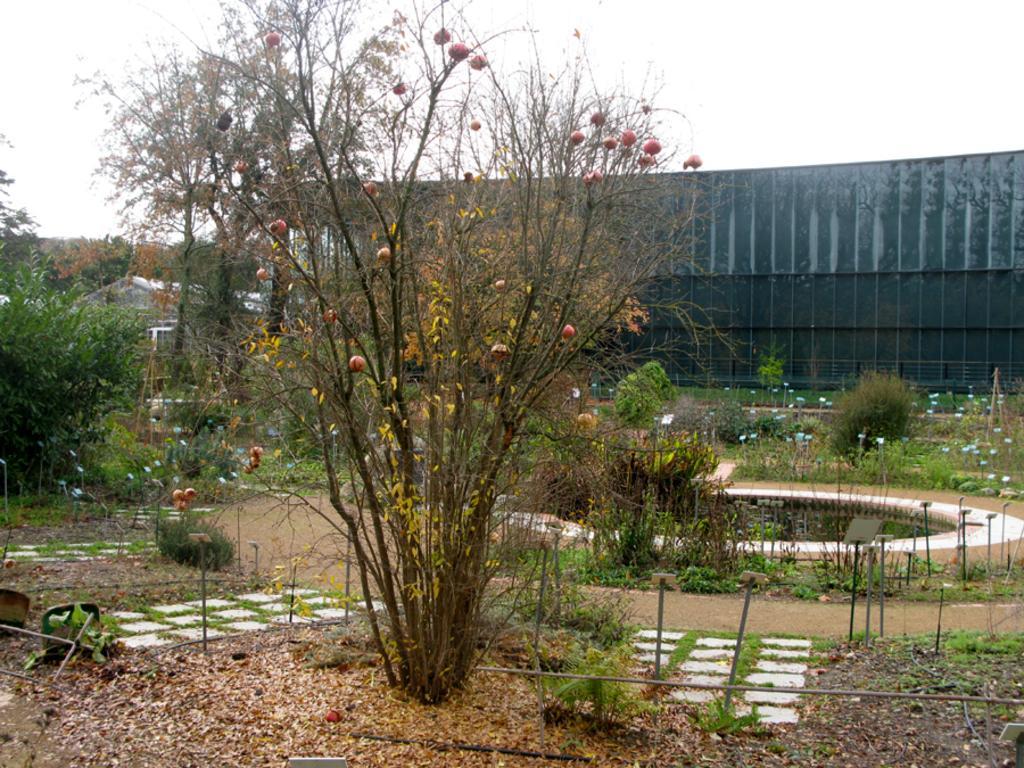Could you give a brief overview of what you see in this image? In this image, we can see some plants and trees. There is a building in the middle of the image. There is a pond on the right side of the image. There is a sky at the top of the image. 